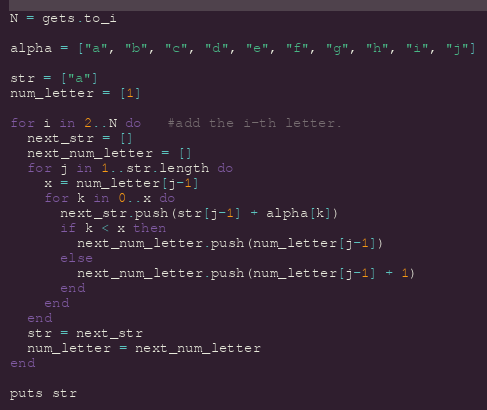Convert code to text. <code><loc_0><loc_0><loc_500><loc_500><_Ruby_>N = gets.to_i

alpha = ["a", "b", "c", "d", "e", "f", "g", "h", "i", "j"]

str = ["a"]
num_letter = [1]

for i in 2..N do   #add the i-th letter.
  next_str = []
  next_num_letter = []
  for j in 1..str.length do
    x = num_letter[j-1]
    for k in 0..x do
      next_str.push(str[j-1] + alpha[k])
      if k < x then
        next_num_letter.push(num_letter[j-1])
      else
        next_num_letter.push(num_letter[j-1] + 1)
      end
    end
  end
  str = next_str
  num_letter = next_num_letter
end

puts str</code> 